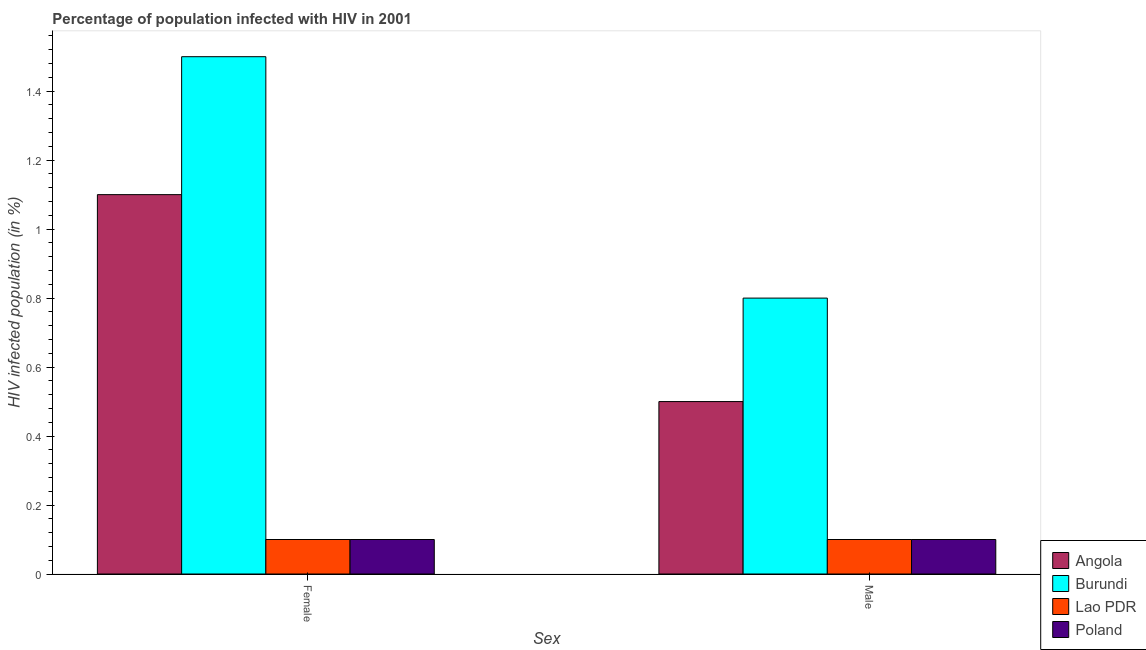How many different coloured bars are there?
Your answer should be compact. 4. Are the number of bars per tick equal to the number of legend labels?
Provide a short and direct response. Yes. Are the number of bars on each tick of the X-axis equal?
Offer a very short reply. Yes. How many bars are there on the 2nd tick from the right?
Provide a succinct answer. 4. What is the label of the 1st group of bars from the left?
Give a very brief answer. Female. Across all countries, what is the maximum percentage of males who are infected with hiv?
Provide a short and direct response. 0.8. In which country was the percentage of females who are infected with hiv maximum?
Give a very brief answer. Burundi. In which country was the percentage of females who are infected with hiv minimum?
Give a very brief answer. Lao PDR. What is the total percentage of females who are infected with hiv in the graph?
Provide a succinct answer. 2.8. What is the difference between the percentage of females who are infected with hiv in Poland and that in Lao PDR?
Provide a short and direct response. 0. What is the average percentage of males who are infected with hiv per country?
Make the answer very short. 0.38. In how many countries, is the percentage of males who are infected with hiv greater than 0.2 %?
Your answer should be compact. 2. In how many countries, is the percentage of males who are infected with hiv greater than the average percentage of males who are infected with hiv taken over all countries?
Keep it short and to the point. 2. What does the 1st bar from the left in Female represents?
Your answer should be very brief. Angola. What does the 4th bar from the right in Female represents?
Offer a terse response. Angola. How many bars are there?
Make the answer very short. 8. Are all the bars in the graph horizontal?
Offer a very short reply. No. How many countries are there in the graph?
Offer a terse response. 4. Are the values on the major ticks of Y-axis written in scientific E-notation?
Offer a terse response. No. What is the title of the graph?
Provide a short and direct response. Percentage of population infected with HIV in 2001. Does "Mauritius" appear as one of the legend labels in the graph?
Your answer should be very brief. No. What is the label or title of the X-axis?
Provide a short and direct response. Sex. What is the label or title of the Y-axis?
Your answer should be very brief. HIV infected population (in %). What is the HIV infected population (in %) of Angola in Female?
Your answer should be compact. 1.1. What is the HIV infected population (in %) of Burundi in Male?
Keep it short and to the point. 0.8. What is the HIV infected population (in %) in Poland in Male?
Give a very brief answer. 0.1. Across all Sex, what is the maximum HIV infected population (in %) of Burundi?
Provide a short and direct response. 1.5. Across all Sex, what is the maximum HIV infected population (in %) in Lao PDR?
Offer a very short reply. 0.1. Across all Sex, what is the minimum HIV infected population (in %) of Burundi?
Give a very brief answer. 0.8. What is the total HIV infected population (in %) of Angola in the graph?
Keep it short and to the point. 1.6. What is the total HIV infected population (in %) of Burundi in the graph?
Your response must be concise. 2.3. What is the total HIV infected population (in %) in Lao PDR in the graph?
Ensure brevity in your answer.  0.2. What is the total HIV infected population (in %) in Poland in the graph?
Provide a succinct answer. 0.2. What is the difference between the HIV infected population (in %) of Angola in Female and that in Male?
Provide a short and direct response. 0.6. What is the difference between the HIV infected population (in %) in Angola in Female and the HIV infected population (in %) in Poland in Male?
Your answer should be very brief. 1. What is the difference between the HIV infected population (in %) of Burundi in Female and the HIV infected population (in %) of Lao PDR in Male?
Ensure brevity in your answer.  1.4. What is the average HIV infected population (in %) of Angola per Sex?
Your response must be concise. 0.8. What is the average HIV infected population (in %) of Burundi per Sex?
Give a very brief answer. 1.15. What is the difference between the HIV infected population (in %) in Angola and HIV infected population (in %) in Lao PDR in Female?
Ensure brevity in your answer.  1. What is the difference between the HIV infected population (in %) of Burundi and HIV infected population (in %) of Lao PDR in Female?
Provide a succinct answer. 1.4. What is the difference between the HIV infected population (in %) in Angola and HIV infected population (in %) in Burundi in Male?
Your answer should be very brief. -0.3. What is the difference between the HIV infected population (in %) in Burundi and HIV infected population (in %) in Poland in Male?
Ensure brevity in your answer.  0.7. What is the difference between the HIV infected population (in %) of Lao PDR and HIV infected population (in %) of Poland in Male?
Provide a short and direct response. 0. What is the ratio of the HIV infected population (in %) of Burundi in Female to that in Male?
Your response must be concise. 1.88. What is the ratio of the HIV infected population (in %) of Lao PDR in Female to that in Male?
Your answer should be compact. 1. What is the ratio of the HIV infected population (in %) of Poland in Female to that in Male?
Keep it short and to the point. 1. What is the difference between the highest and the second highest HIV infected population (in %) in Angola?
Provide a succinct answer. 0.6. What is the difference between the highest and the second highest HIV infected population (in %) of Burundi?
Provide a succinct answer. 0.7. What is the difference between the highest and the second highest HIV infected population (in %) in Lao PDR?
Keep it short and to the point. 0. What is the difference between the highest and the second highest HIV infected population (in %) in Poland?
Keep it short and to the point. 0. What is the difference between the highest and the lowest HIV infected population (in %) of Angola?
Offer a very short reply. 0.6. What is the difference between the highest and the lowest HIV infected population (in %) of Burundi?
Offer a very short reply. 0.7. 